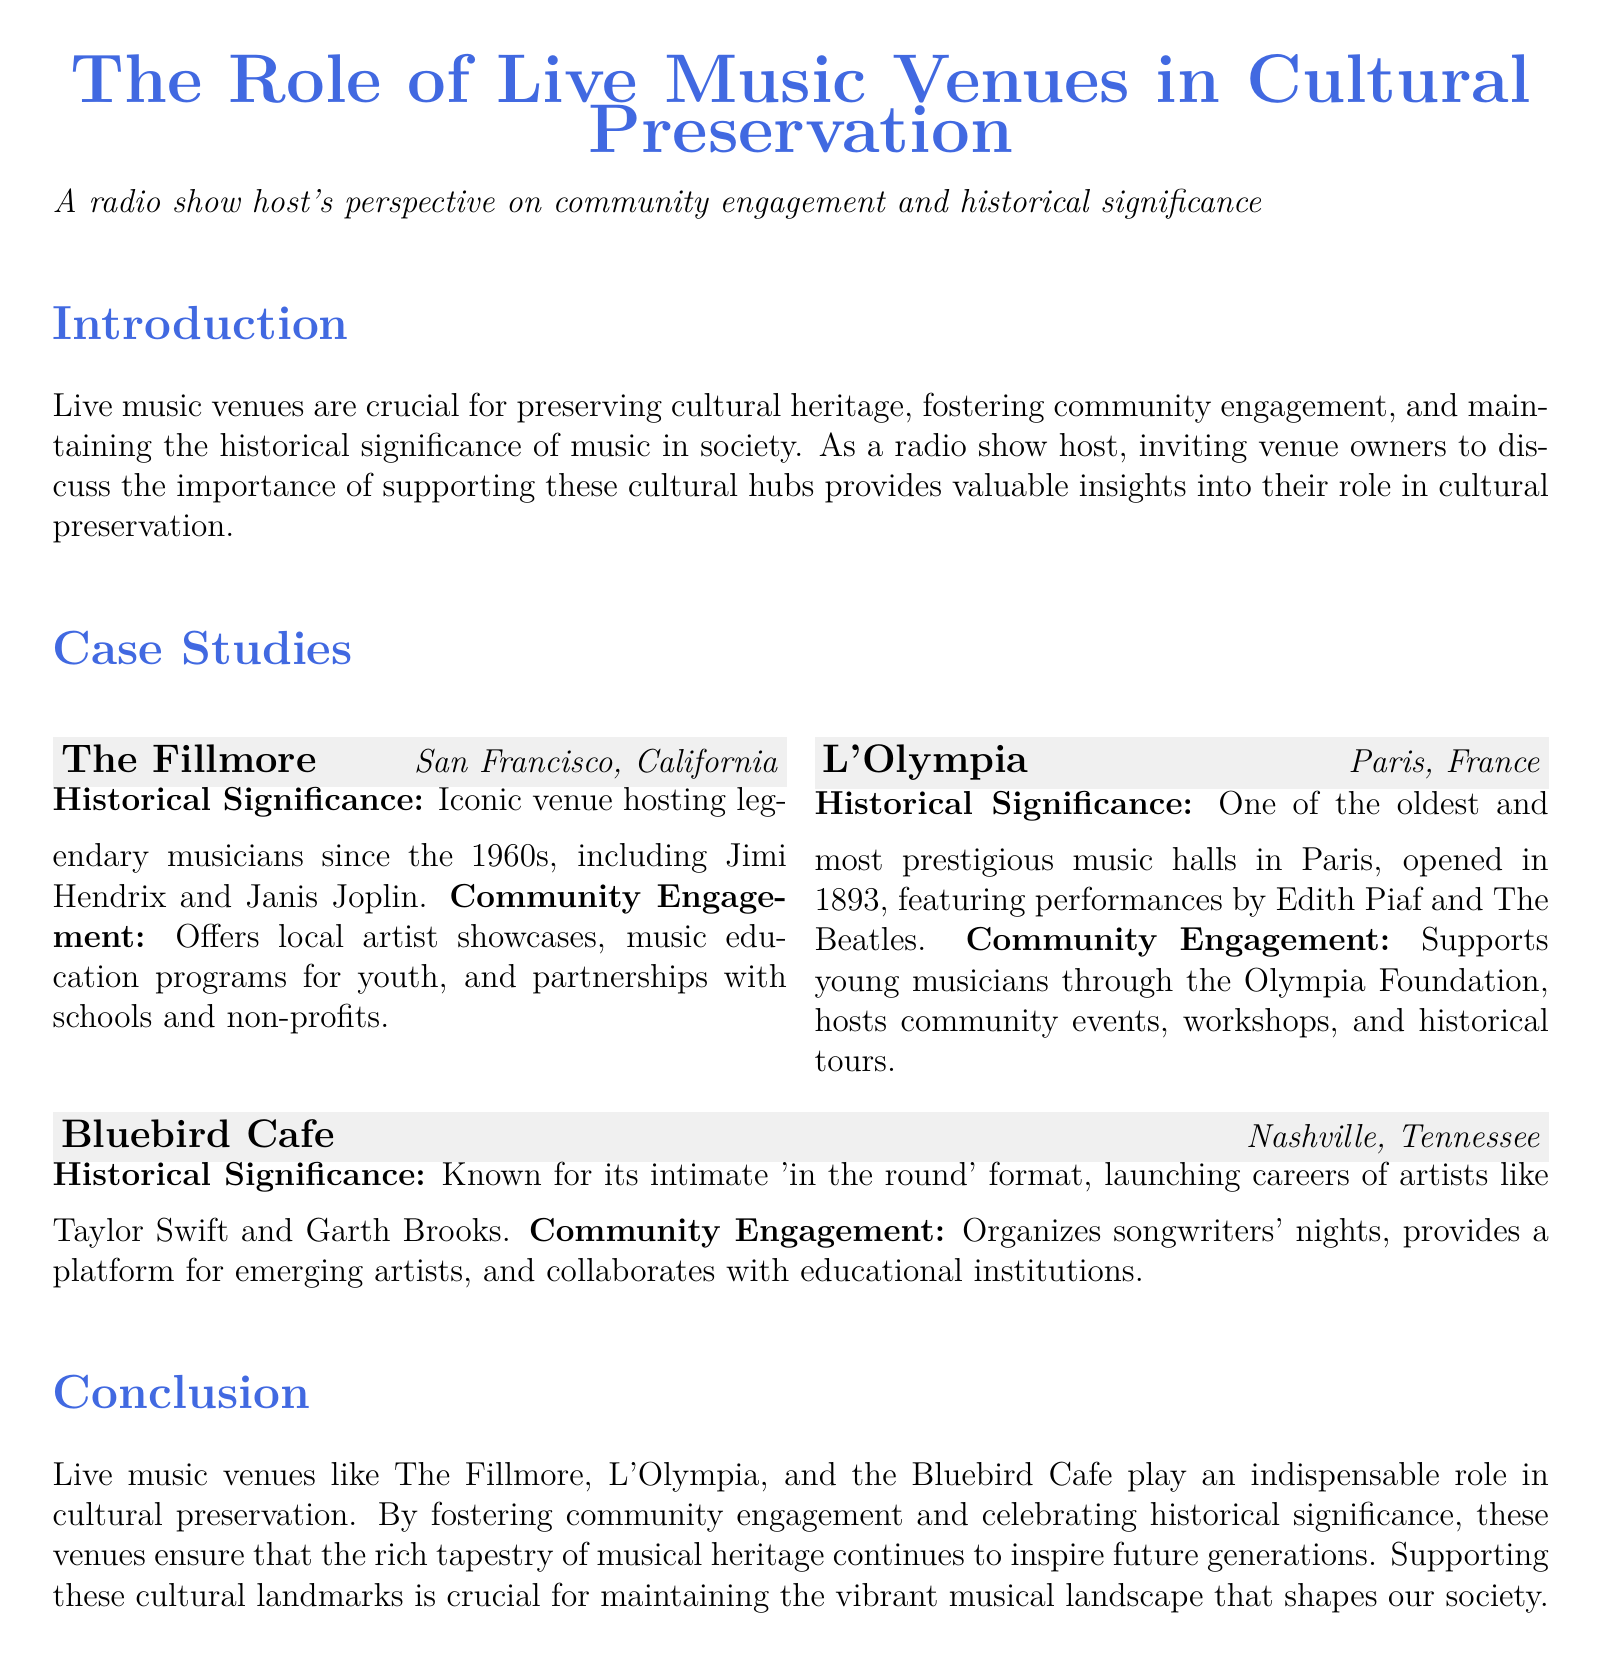What is the name of the venue located in San Francisco? The venue located in San Francisco is The Fillmore.
Answer: The Fillmore In what year did L'Olympia open? L'Olympia opened in the year 1893.
Answer: 1893 Which famous artists have performed at The Fillmore? The Fillmore has hosted legendary musicians including Jimi Hendrix and Janis Joplin.
Answer: Jimi Hendrix and Janis Joplin What type of community engagement does the Bluebird Cafe organize? The Bluebird Cafe organizes songwriters' nights and provides a platform for emerging artists.
Answer: Songwriters' nights What is the significance of the Bluebird Cafe's performance format? The Bluebird Cafe is known for its intimate 'in the round' format.
Answer: 'In the round' format Which foundation supports young musicians at L'Olympia? The foundation that supports young musicians at L'Olympia is the Olympia Foundation.
Answer: Olympia Foundation How long has The Fillmore been hosting musicians? The Fillmore has been hosting musicians since the 1960s.
Answer: Since the 1960s What is the overall theme of the document? The overall theme of the document is the role of live music venues in cultural preservation.
Answer: Cultural preservation 